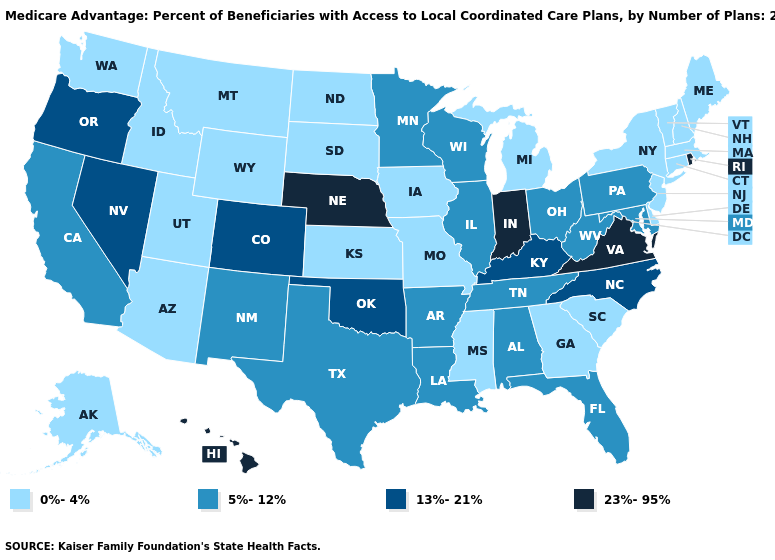What is the value of Kentucky?
Give a very brief answer. 13%-21%. Name the states that have a value in the range 13%-21%?
Keep it brief. Colorado, Kentucky, North Carolina, Nevada, Oklahoma, Oregon. What is the value of Wyoming?
Be succinct. 0%-4%. Does Oklahoma have the lowest value in the USA?
Be succinct. No. Name the states that have a value in the range 0%-4%?
Keep it brief. Alaska, Arizona, Connecticut, Delaware, Georgia, Iowa, Idaho, Kansas, Massachusetts, Maine, Michigan, Missouri, Mississippi, Montana, North Dakota, New Hampshire, New Jersey, New York, South Carolina, South Dakota, Utah, Vermont, Washington, Wyoming. Name the states that have a value in the range 5%-12%?
Answer briefly. Alabama, Arkansas, California, Florida, Illinois, Louisiana, Maryland, Minnesota, New Mexico, Ohio, Pennsylvania, Tennessee, Texas, Wisconsin, West Virginia. What is the value of Utah?
Quick response, please. 0%-4%. What is the value of Mississippi?
Write a very short answer. 0%-4%. Does New Mexico have a lower value than North Dakota?
Be succinct. No. Name the states that have a value in the range 23%-95%?
Give a very brief answer. Hawaii, Indiana, Nebraska, Rhode Island, Virginia. Which states have the highest value in the USA?
Give a very brief answer. Hawaii, Indiana, Nebraska, Rhode Island, Virginia. What is the lowest value in the MidWest?
Short answer required. 0%-4%. Does Maryland have a lower value than Kentucky?
Keep it brief. Yes. Does Nevada have the same value as Wisconsin?
Write a very short answer. No. Does Nebraska have the lowest value in the MidWest?
Give a very brief answer. No. 